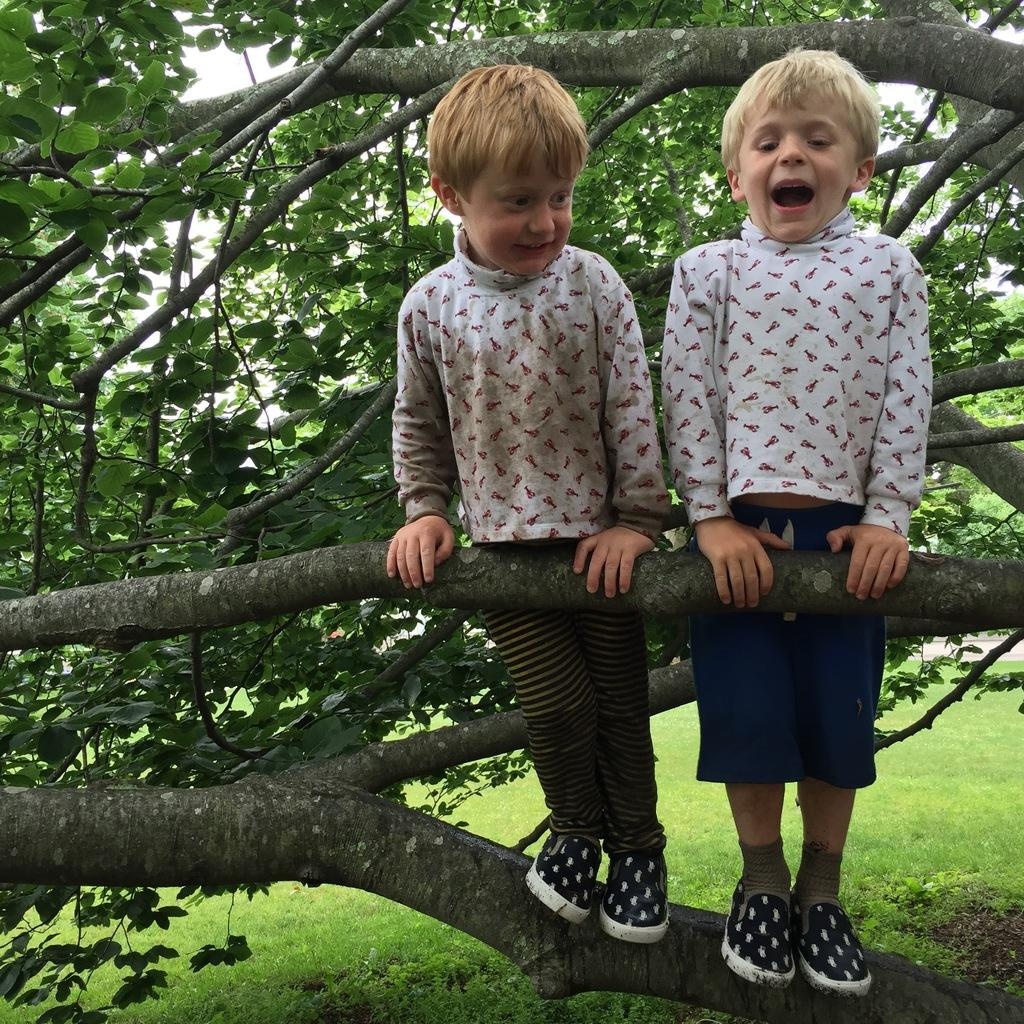How many people are in the image? There are two boys in the image. What are the boys doing in the image? The boys are standing on a branch of a tree. What can be seen in the background of the image? There is grass visible in the background of the image. What type of skin condition can be seen on the doctor's face in the image? There is no doctor present in the image, and therefore no skin condition can be observed. 